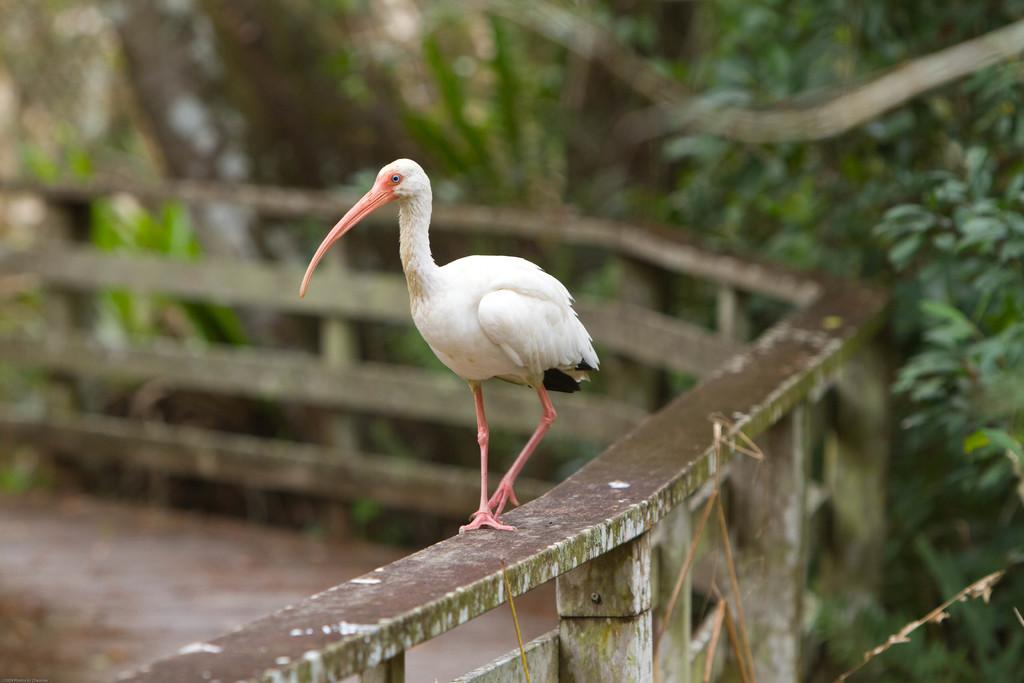What animal is present in the image? There is a duck in the image. Where is the duck located? The duck is on a railing. What can be seen in the background of the image? There are trees in the background of the image. What type of toys can be seen in the image? There are no toys present in the image; it features a duck on a railing with trees in the background. 